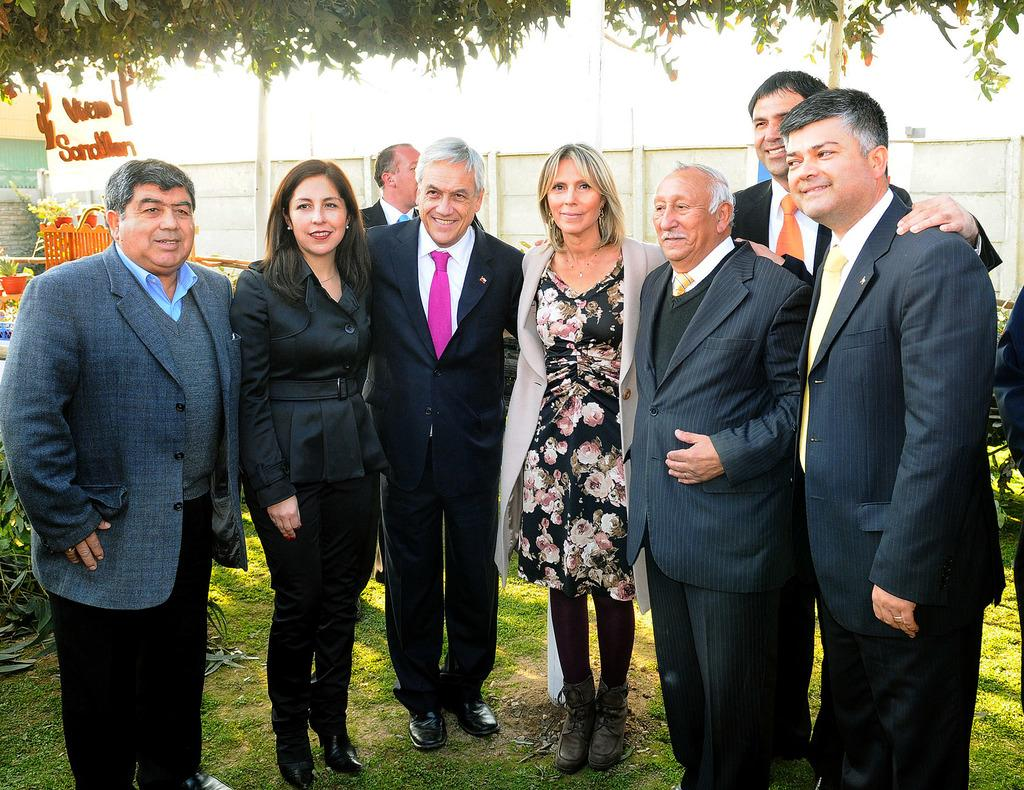What can be seen in the image? There are people standing in the image. What is the surface beneath the people's feet? The ground is visible in the image, and it is covered with grass. What can be seen in the distance in the image? There are trees visible in the background of the image. What type of net can be seen hanging from the trees in the image? There is no net present in the image; it features people standing on grassy ground with trees in the background. 